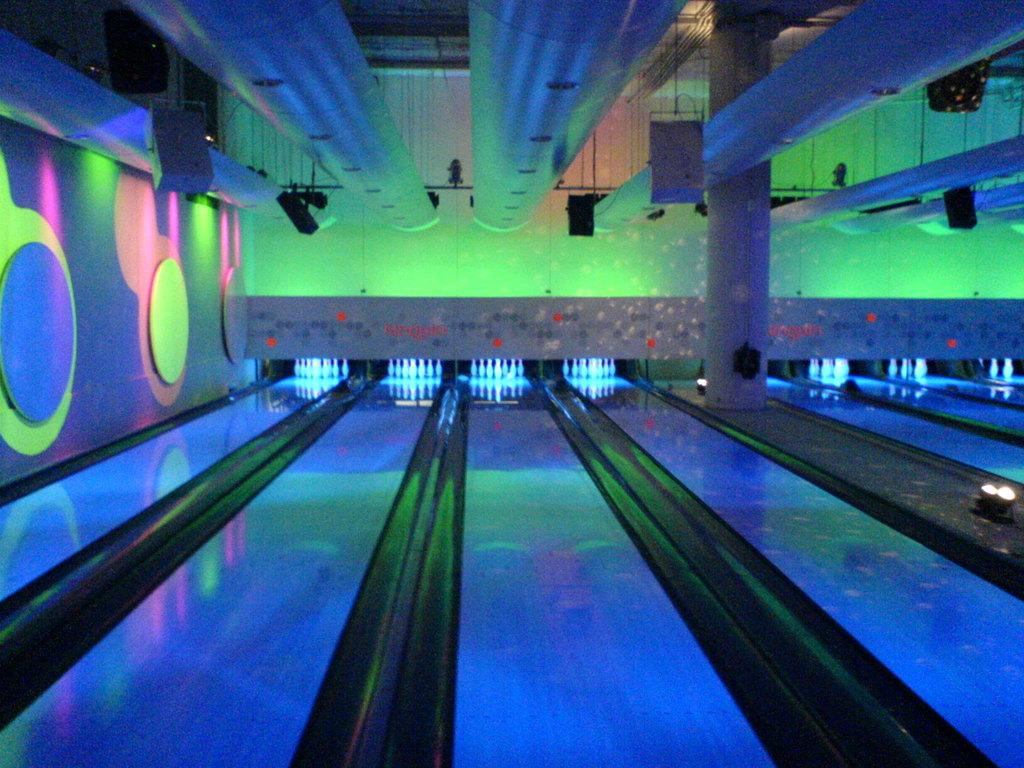What is the main subject of the image? The main subject of the image is a bowling game platform. What can be seen in front of the platform? There are white color bowling pins in the front of the platform. What is the lighting like in the image? There is colorful lighting on the wall beside the platform. What type of surprise can be seen in the image? There is no surprise present in the image; it features a bowling game platform with bowling pins and colorful lighting. What material is the plastic support used for the bowling pins made of? There is no plastic support mentioned in the image; the bowling pins are simply placed on the platform. 